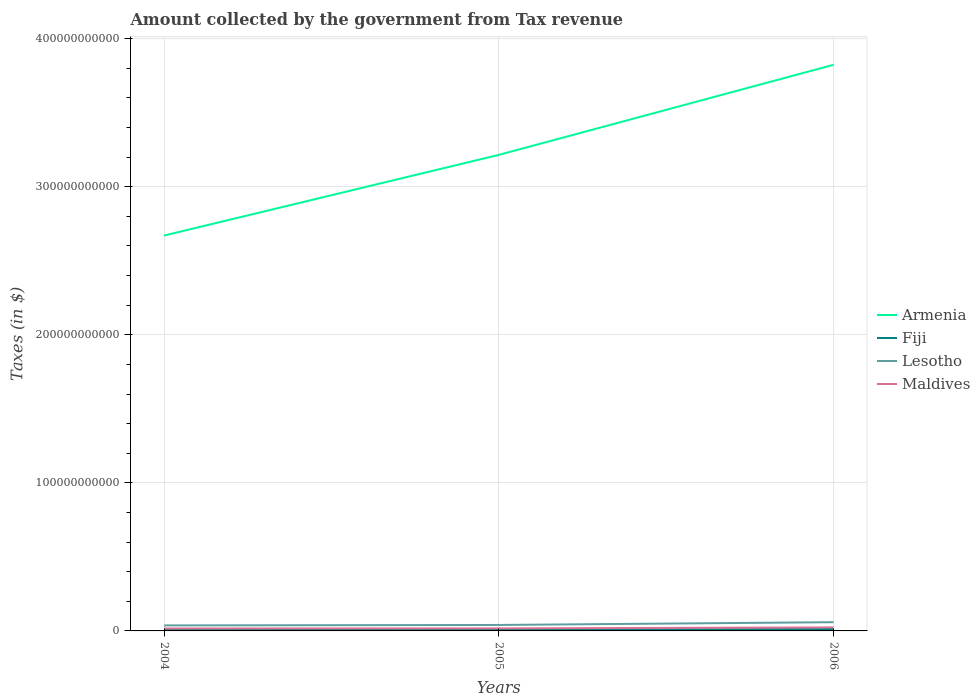How many different coloured lines are there?
Your answer should be very brief. 4. Is the number of lines equal to the number of legend labels?
Make the answer very short. Yes. Across all years, what is the maximum amount collected by the government from tax revenue in Lesotho?
Provide a short and direct response. 3.72e+09. In which year was the amount collected by the government from tax revenue in Lesotho maximum?
Your answer should be compact. 2004. What is the total amount collected by the government from tax revenue in Fiji in the graph?
Your response must be concise. -3.65e+07. What is the difference between the highest and the second highest amount collected by the government from tax revenue in Lesotho?
Give a very brief answer. 2.18e+09. How many lines are there?
Your response must be concise. 4. What is the difference between two consecutive major ticks on the Y-axis?
Ensure brevity in your answer.  1.00e+11. Are the values on the major ticks of Y-axis written in scientific E-notation?
Your response must be concise. No. Does the graph contain grids?
Offer a very short reply. Yes. How many legend labels are there?
Ensure brevity in your answer.  4. What is the title of the graph?
Ensure brevity in your answer.  Amount collected by the government from Tax revenue. What is the label or title of the X-axis?
Make the answer very short. Years. What is the label or title of the Y-axis?
Give a very brief answer. Taxes (in $). What is the Taxes (in $) of Armenia in 2004?
Give a very brief answer. 2.67e+11. What is the Taxes (in $) of Fiji in 2004?
Ensure brevity in your answer.  1.05e+09. What is the Taxes (in $) in Lesotho in 2004?
Offer a terse response. 3.72e+09. What is the Taxes (in $) in Maldives in 2004?
Offer a terse response. 1.65e+09. What is the Taxes (in $) in Armenia in 2005?
Your answer should be very brief. 3.22e+11. What is the Taxes (in $) in Fiji in 2005?
Ensure brevity in your answer.  1.09e+09. What is the Taxes (in $) in Lesotho in 2005?
Give a very brief answer. 4.02e+09. What is the Taxes (in $) of Maldives in 2005?
Offer a terse response. 1.72e+09. What is the Taxes (in $) in Armenia in 2006?
Provide a short and direct response. 3.82e+11. What is the Taxes (in $) of Fiji in 2006?
Provide a succinct answer. 1.25e+09. What is the Taxes (in $) in Lesotho in 2006?
Your answer should be compact. 5.90e+09. What is the Taxes (in $) of Maldives in 2006?
Make the answer very short. 2.37e+09. Across all years, what is the maximum Taxes (in $) of Armenia?
Your response must be concise. 3.82e+11. Across all years, what is the maximum Taxes (in $) of Fiji?
Provide a succinct answer. 1.25e+09. Across all years, what is the maximum Taxes (in $) in Lesotho?
Give a very brief answer. 5.90e+09. Across all years, what is the maximum Taxes (in $) of Maldives?
Ensure brevity in your answer.  2.37e+09. Across all years, what is the minimum Taxes (in $) in Armenia?
Offer a terse response. 2.67e+11. Across all years, what is the minimum Taxes (in $) in Fiji?
Offer a terse response. 1.05e+09. Across all years, what is the minimum Taxes (in $) of Lesotho?
Provide a short and direct response. 3.72e+09. Across all years, what is the minimum Taxes (in $) in Maldives?
Ensure brevity in your answer.  1.65e+09. What is the total Taxes (in $) in Armenia in the graph?
Your response must be concise. 9.71e+11. What is the total Taxes (in $) in Fiji in the graph?
Make the answer very short. 3.38e+09. What is the total Taxes (in $) of Lesotho in the graph?
Offer a very short reply. 1.36e+1. What is the total Taxes (in $) of Maldives in the graph?
Ensure brevity in your answer.  5.74e+09. What is the difference between the Taxes (in $) of Armenia in 2004 and that in 2005?
Provide a short and direct response. -5.45e+1. What is the difference between the Taxes (in $) in Fiji in 2004 and that in 2005?
Provide a succinct answer. -3.65e+07. What is the difference between the Taxes (in $) in Lesotho in 2004 and that in 2005?
Your response must be concise. -2.95e+08. What is the difference between the Taxes (in $) in Maldives in 2004 and that in 2005?
Your answer should be compact. -7.56e+07. What is the difference between the Taxes (in $) in Armenia in 2004 and that in 2006?
Provide a short and direct response. -1.15e+11. What is the difference between the Taxes (in $) of Fiji in 2004 and that in 2006?
Offer a very short reply. -1.97e+08. What is the difference between the Taxes (in $) of Lesotho in 2004 and that in 2006?
Offer a terse response. -2.18e+09. What is the difference between the Taxes (in $) of Maldives in 2004 and that in 2006?
Your response must be concise. -7.23e+08. What is the difference between the Taxes (in $) in Armenia in 2005 and that in 2006?
Give a very brief answer. -6.09e+1. What is the difference between the Taxes (in $) in Fiji in 2005 and that in 2006?
Ensure brevity in your answer.  -1.60e+08. What is the difference between the Taxes (in $) in Lesotho in 2005 and that in 2006?
Keep it short and to the point. -1.88e+09. What is the difference between the Taxes (in $) of Maldives in 2005 and that in 2006?
Keep it short and to the point. -6.48e+08. What is the difference between the Taxes (in $) of Armenia in 2004 and the Taxes (in $) of Fiji in 2005?
Your answer should be very brief. 2.66e+11. What is the difference between the Taxes (in $) of Armenia in 2004 and the Taxes (in $) of Lesotho in 2005?
Keep it short and to the point. 2.63e+11. What is the difference between the Taxes (in $) in Armenia in 2004 and the Taxes (in $) in Maldives in 2005?
Your answer should be compact. 2.65e+11. What is the difference between the Taxes (in $) of Fiji in 2004 and the Taxes (in $) of Lesotho in 2005?
Give a very brief answer. -2.97e+09. What is the difference between the Taxes (in $) in Fiji in 2004 and the Taxes (in $) in Maldives in 2005?
Provide a short and direct response. -6.74e+08. What is the difference between the Taxes (in $) in Lesotho in 2004 and the Taxes (in $) in Maldives in 2005?
Ensure brevity in your answer.  2.00e+09. What is the difference between the Taxes (in $) in Armenia in 2004 and the Taxes (in $) in Fiji in 2006?
Give a very brief answer. 2.66e+11. What is the difference between the Taxes (in $) in Armenia in 2004 and the Taxes (in $) in Lesotho in 2006?
Offer a terse response. 2.61e+11. What is the difference between the Taxes (in $) of Armenia in 2004 and the Taxes (in $) of Maldives in 2006?
Offer a very short reply. 2.65e+11. What is the difference between the Taxes (in $) of Fiji in 2004 and the Taxes (in $) of Lesotho in 2006?
Your answer should be very brief. -4.86e+09. What is the difference between the Taxes (in $) in Fiji in 2004 and the Taxes (in $) in Maldives in 2006?
Give a very brief answer. -1.32e+09. What is the difference between the Taxes (in $) in Lesotho in 2004 and the Taxes (in $) in Maldives in 2006?
Provide a succinct answer. 1.35e+09. What is the difference between the Taxes (in $) in Armenia in 2005 and the Taxes (in $) in Fiji in 2006?
Make the answer very short. 3.20e+11. What is the difference between the Taxes (in $) in Armenia in 2005 and the Taxes (in $) in Lesotho in 2006?
Ensure brevity in your answer.  3.16e+11. What is the difference between the Taxes (in $) in Armenia in 2005 and the Taxes (in $) in Maldives in 2006?
Offer a very short reply. 3.19e+11. What is the difference between the Taxes (in $) of Fiji in 2005 and the Taxes (in $) of Lesotho in 2006?
Provide a succinct answer. -4.82e+09. What is the difference between the Taxes (in $) in Fiji in 2005 and the Taxes (in $) in Maldives in 2006?
Provide a succinct answer. -1.28e+09. What is the difference between the Taxes (in $) in Lesotho in 2005 and the Taxes (in $) in Maldives in 2006?
Offer a very short reply. 1.65e+09. What is the average Taxes (in $) of Armenia per year?
Provide a succinct answer. 3.24e+11. What is the average Taxes (in $) in Fiji per year?
Your answer should be compact. 1.13e+09. What is the average Taxes (in $) in Lesotho per year?
Provide a short and direct response. 4.55e+09. What is the average Taxes (in $) in Maldives per year?
Provide a short and direct response. 1.91e+09. In the year 2004, what is the difference between the Taxes (in $) of Armenia and Taxes (in $) of Fiji?
Give a very brief answer. 2.66e+11. In the year 2004, what is the difference between the Taxes (in $) of Armenia and Taxes (in $) of Lesotho?
Offer a very short reply. 2.63e+11. In the year 2004, what is the difference between the Taxes (in $) of Armenia and Taxes (in $) of Maldives?
Offer a very short reply. 2.65e+11. In the year 2004, what is the difference between the Taxes (in $) in Fiji and Taxes (in $) in Lesotho?
Provide a short and direct response. -2.68e+09. In the year 2004, what is the difference between the Taxes (in $) in Fiji and Taxes (in $) in Maldives?
Your response must be concise. -5.98e+08. In the year 2004, what is the difference between the Taxes (in $) of Lesotho and Taxes (in $) of Maldives?
Offer a very short reply. 2.08e+09. In the year 2005, what is the difference between the Taxes (in $) of Armenia and Taxes (in $) of Fiji?
Keep it short and to the point. 3.20e+11. In the year 2005, what is the difference between the Taxes (in $) of Armenia and Taxes (in $) of Lesotho?
Keep it short and to the point. 3.18e+11. In the year 2005, what is the difference between the Taxes (in $) in Armenia and Taxes (in $) in Maldives?
Ensure brevity in your answer.  3.20e+11. In the year 2005, what is the difference between the Taxes (in $) in Fiji and Taxes (in $) in Lesotho?
Provide a succinct answer. -2.93e+09. In the year 2005, what is the difference between the Taxes (in $) in Fiji and Taxes (in $) in Maldives?
Your answer should be compact. -6.37e+08. In the year 2005, what is the difference between the Taxes (in $) of Lesotho and Taxes (in $) of Maldives?
Your response must be concise. 2.30e+09. In the year 2006, what is the difference between the Taxes (in $) of Armenia and Taxes (in $) of Fiji?
Provide a succinct answer. 3.81e+11. In the year 2006, what is the difference between the Taxes (in $) in Armenia and Taxes (in $) in Lesotho?
Give a very brief answer. 3.76e+11. In the year 2006, what is the difference between the Taxes (in $) in Armenia and Taxes (in $) in Maldives?
Your answer should be very brief. 3.80e+11. In the year 2006, what is the difference between the Taxes (in $) of Fiji and Taxes (in $) of Lesotho?
Provide a succinct answer. -4.66e+09. In the year 2006, what is the difference between the Taxes (in $) in Fiji and Taxes (in $) in Maldives?
Provide a short and direct response. -1.12e+09. In the year 2006, what is the difference between the Taxes (in $) in Lesotho and Taxes (in $) in Maldives?
Provide a succinct answer. 3.53e+09. What is the ratio of the Taxes (in $) of Armenia in 2004 to that in 2005?
Keep it short and to the point. 0.83. What is the ratio of the Taxes (in $) in Fiji in 2004 to that in 2005?
Keep it short and to the point. 0.97. What is the ratio of the Taxes (in $) in Lesotho in 2004 to that in 2005?
Offer a very short reply. 0.93. What is the ratio of the Taxes (in $) in Maldives in 2004 to that in 2005?
Make the answer very short. 0.96. What is the ratio of the Taxes (in $) in Armenia in 2004 to that in 2006?
Offer a very short reply. 0.7. What is the ratio of the Taxes (in $) in Fiji in 2004 to that in 2006?
Offer a terse response. 0.84. What is the ratio of the Taxes (in $) of Lesotho in 2004 to that in 2006?
Keep it short and to the point. 0.63. What is the ratio of the Taxes (in $) in Maldives in 2004 to that in 2006?
Ensure brevity in your answer.  0.69. What is the ratio of the Taxes (in $) of Armenia in 2005 to that in 2006?
Offer a terse response. 0.84. What is the ratio of the Taxes (in $) of Fiji in 2005 to that in 2006?
Provide a succinct answer. 0.87. What is the ratio of the Taxes (in $) of Lesotho in 2005 to that in 2006?
Your answer should be compact. 0.68. What is the ratio of the Taxes (in $) of Maldives in 2005 to that in 2006?
Make the answer very short. 0.73. What is the difference between the highest and the second highest Taxes (in $) of Armenia?
Give a very brief answer. 6.09e+1. What is the difference between the highest and the second highest Taxes (in $) of Fiji?
Provide a succinct answer. 1.60e+08. What is the difference between the highest and the second highest Taxes (in $) in Lesotho?
Provide a succinct answer. 1.88e+09. What is the difference between the highest and the second highest Taxes (in $) in Maldives?
Offer a terse response. 6.48e+08. What is the difference between the highest and the lowest Taxes (in $) of Armenia?
Ensure brevity in your answer.  1.15e+11. What is the difference between the highest and the lowest Taxes (in $) of Fiji?
Keep it short and to the point. 1.97e+08. What is the difference between the highest and the lowest Taxes (in $) of Lesotho?
Provide a succinct answer. 2.18e+09. What is the difference between the highest and the lowest Taxes (in $) of Maldives?
Provide a succinct answer. 7.23e+08. 